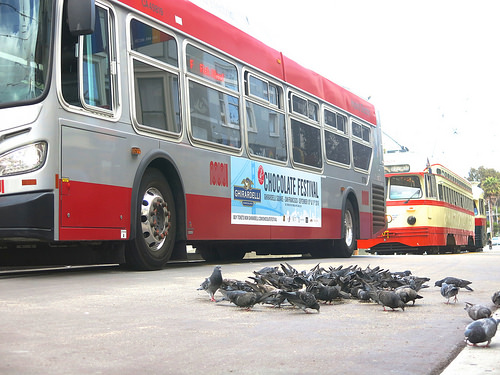<image>
Is there a chocolate above the birds? No. The chocolate is not positioned above the birds. The vertical arrangement shows a different relationship. 